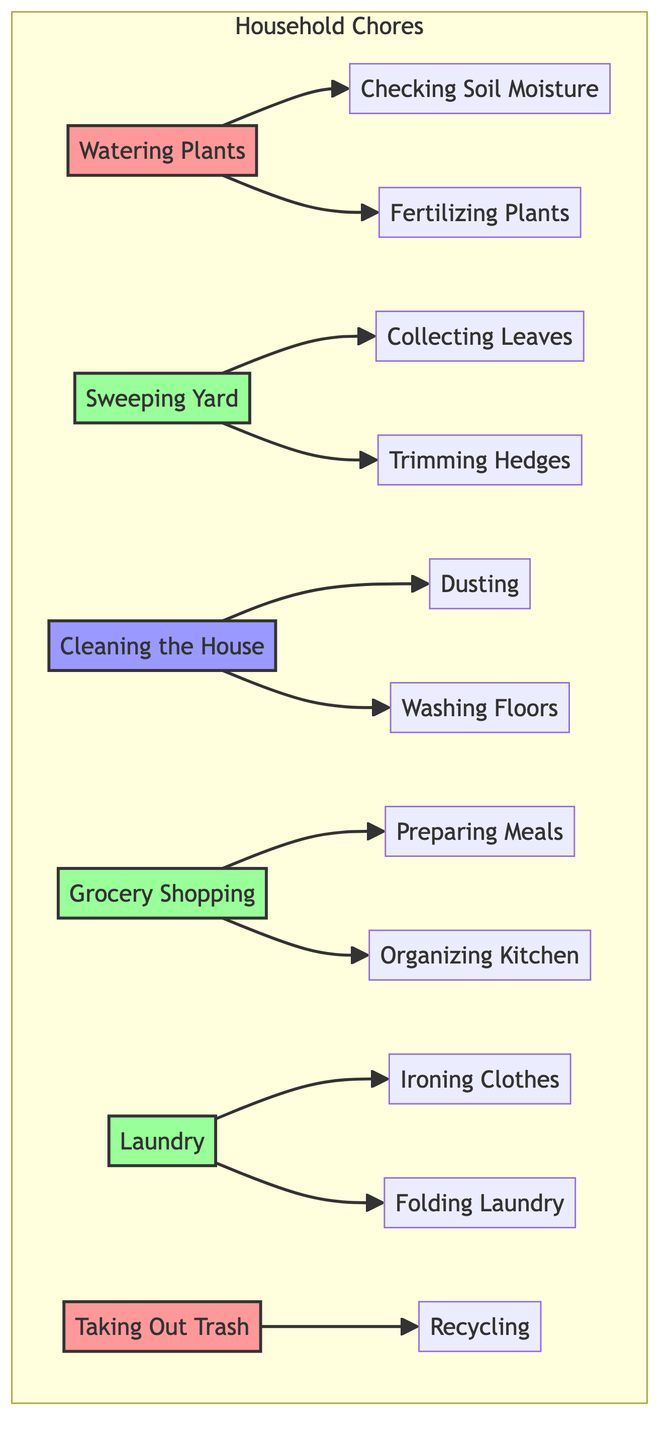What is the frequency of Watering Plants? The task "Watering Plants" is labeled with a frequency of "Daily" in the diagram.
Answer: Daily How many tasks are done Weekly? The tasks categorized as "Weekly" are Sweeping Yard, Grocery Shopping, and Laundry. Counting these gives us a total of 3 weekly tasks.
Answer: 3 What task follows Cleaning the House? Cleaning the House leads to two subsequent tasks: "Dusting" and "Washing Floors". Since the question asks for any task that follows, I can mention either one.
Answer: Dusting Which task is done after Taking Out Trash? The task "Taking Out Trash" has one next task labeled as "Recycling". Therefore, "Recycling" is the task that follows.
Answer: Recycling Which task has the highest frequency? Among all the tasks listed, "Watering Plants" and "Taking Out Trash" are both performed daily. Thus, both tasks share the highest frequency of execution.
Answer: Watering Plants and Taking Out Trash How many daily tasks are there? The diagram shows two tasks performed daily: Watering Plants and Taking Out Trash. Therefore, the total number of daily tasks is 2.
Answer: 2 Which tasks are linked after Grocery Shopping? Following Grocery Shopping, the tasks that come next are "Preparing Meals" and "Organizing Kitchen". So, both tasks are linked afterwards.
Answer: Preparing Meals and Organizing Kitchen What is the relationship between Cleaning the House and Dusting? The relationship is that Cleaning the House precedes Dusting, indicating that Dusting is a task that follows Cleaning the House.
Answer: Cleaning the House precedes Dusting How many tasks are linked to Sweeping Yard? Sweeping Yard leads to two tasks: "Collecting Leaves" and "Trimming Hedges", which means there are a total of 2 linked tasks.
Answer: 2 What type of diagram is presented here? The presented diagram is a Directed Graph, representing relationships between tasks and their execution frequencies.
Answer: Directed Graph 